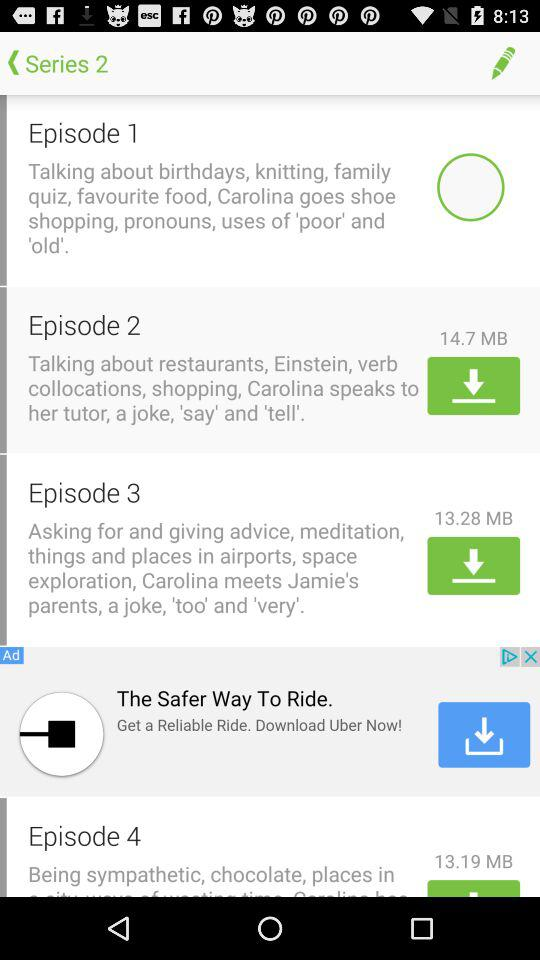What is the size of the download file of Episode 3? The size of the download file is 13.28 MB. 